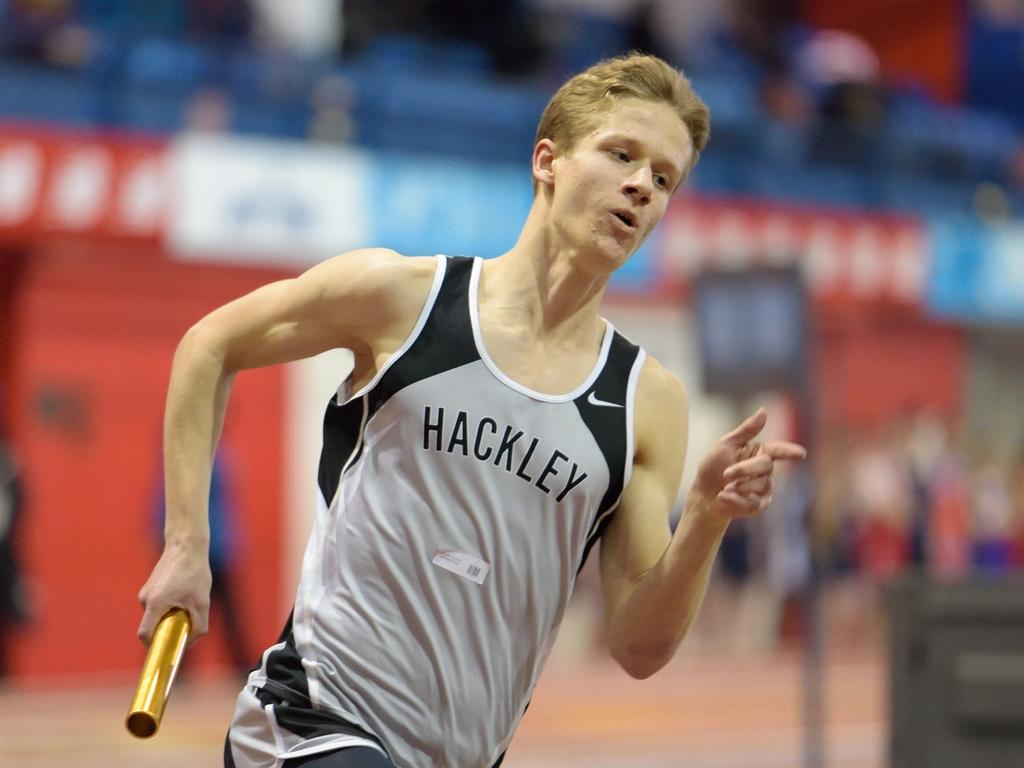What is happening in the image? There is a person in the image, and they are running. What is the person holding in their hand? The person is holding an object in their hand. Can you describe the background of the image? The background of the image is blurred. Is the person playing with a water toy in the image? There is no water toy present in the image. 